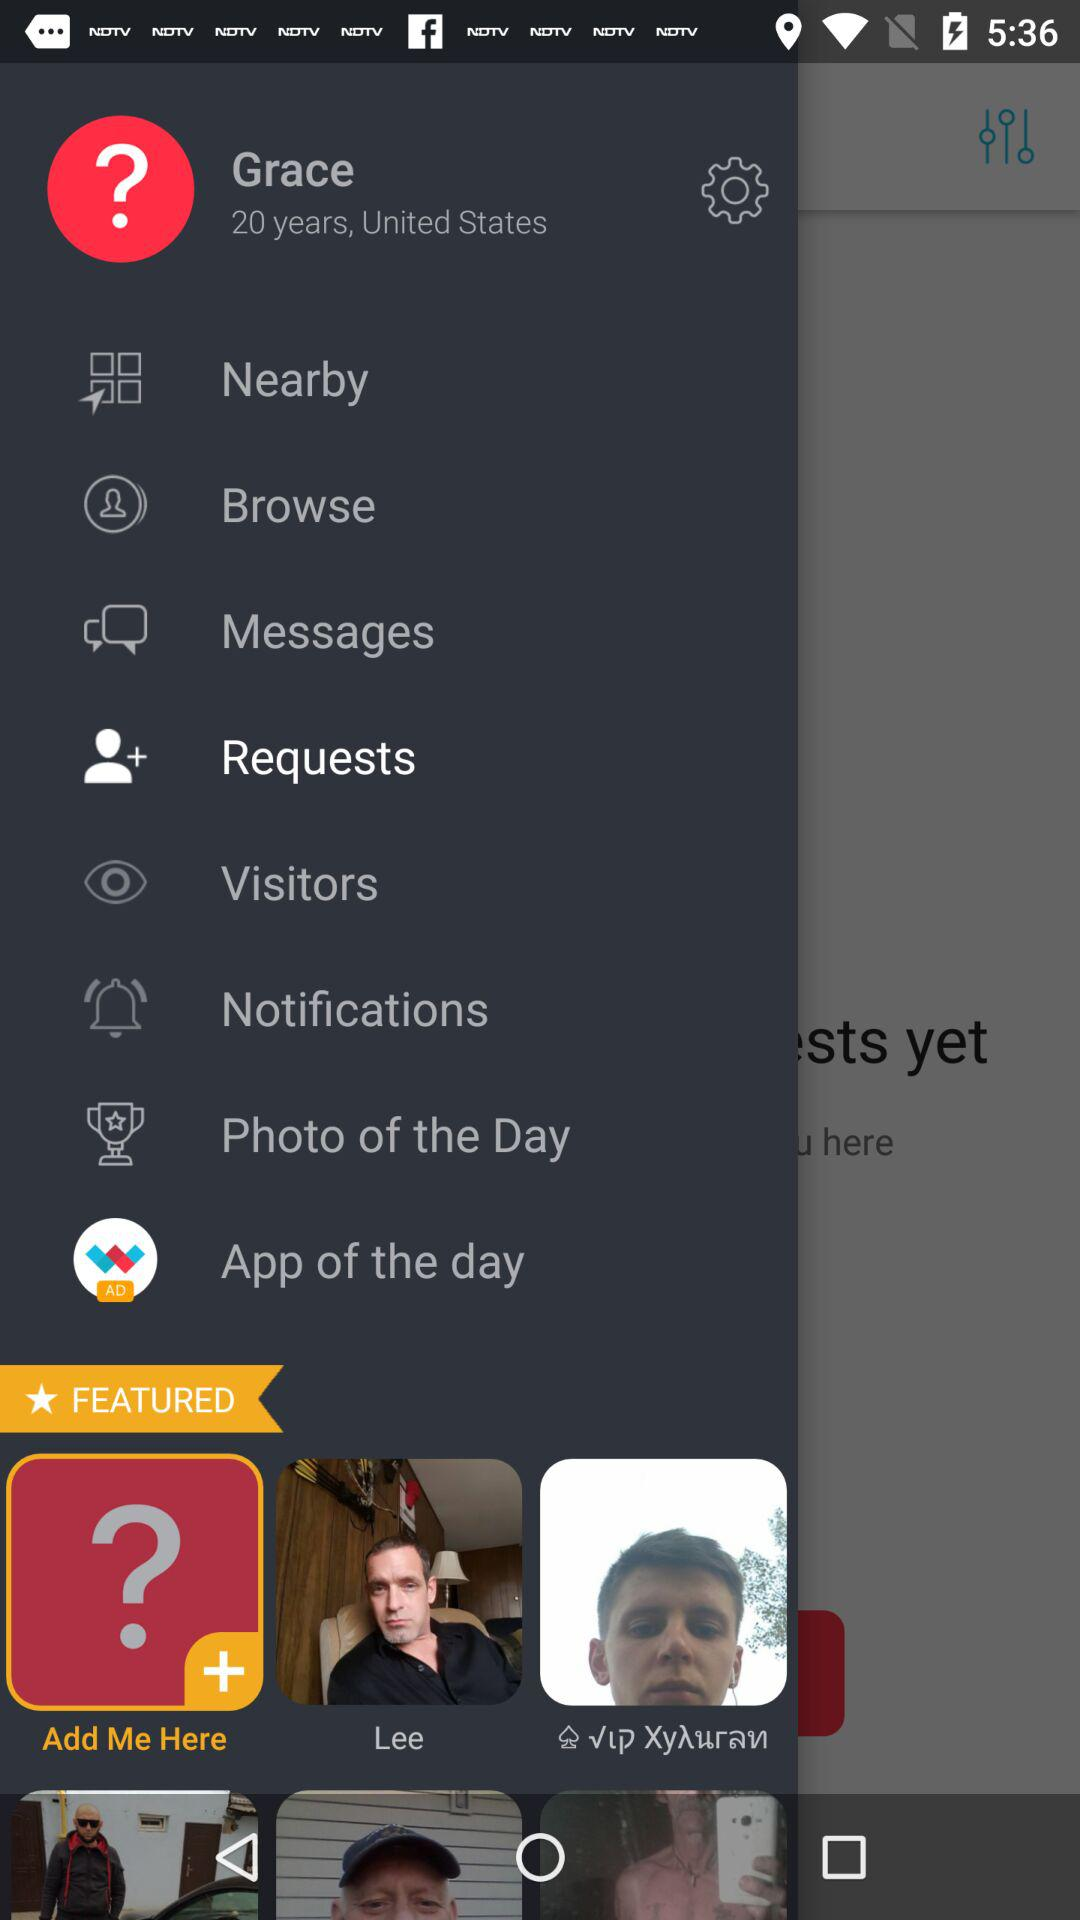What is the user name? The user name is Grace. 